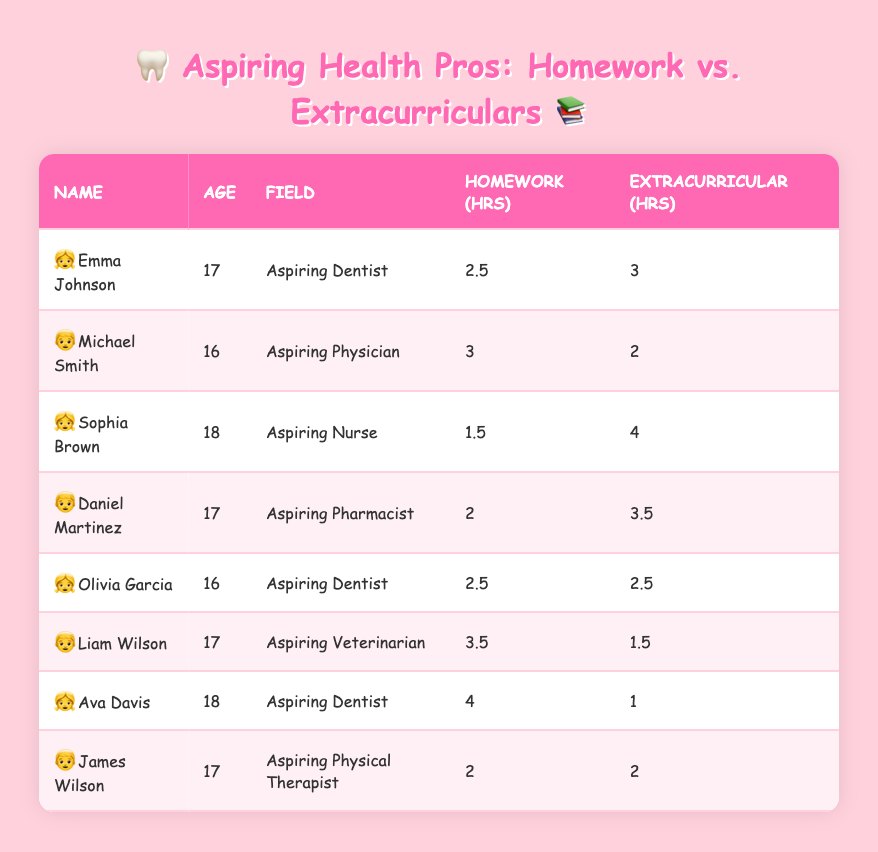What is the name of the student who spends the most time on homework? Looking at the table, Ava Davis spends the most time on homework with 4 hours.
Answer: Ava Davis How many hours does Emma Johnson spend on extracurricular activities? From the table, Emma Johnson spends 3 hours on extracurricular activities.
Answer: 3 hours Which student is aspiring to be a Nurse? Sophia Brown is listed in the table as an aspiring Nurse.
Answer: Sophia Brown What is the total time spent on homework by all students? Adding all the homework hours gives: 2.5 + 3 + 1.5 + 2 + 2.5 + 3.5 + 4 + 2 = 21.
Answer: 21 hours Is it true that Olivia Garcia spends more time on homework than on extracurricular activities? By comparing the hours, Olivia spends 2.5 hours on homework and 2.5 on extracurricular activities, so they are equal. Hence, it's false.
Answer: No What is the average time spent on extracurricular activities among all students? Add the extracurricular hours: 3 + 2 + 4 + 3.5 + 2.5 + 1.5 + 1 + 2 = 20. The average is 20/8 = 2.5.
Answer: 2.5 hours Which student spends the least amount of time on homework, and how much do they spend? Looking through the homework hours, Sophia Brown spends the least time, which is 1.5 hours.
Answer: Sophia Brown, 1.5 hours How many students aspire to be Dentists? Checking the table, there are three students: Emma Johnson, Olivia Garcia, and Ava Davis.
Answer: 3 students What is the difference in homework hours between the student who spends the most and the one who spends the least? The most is 4 hours (Ava Davis), and the least is 1.5 hours (Sophia Brown). The difference is 4 - 1.5 = 2.5 hours.
Answer: 2.5 hours Which aspiring health professional spends the same amount of time on homework and extracurricular activities? By checking the table, Olivia Garcia spends 2.5 hours on homework and 2.5 on extracurriculars, so they are the same.
Answer: Olivia Garcia 